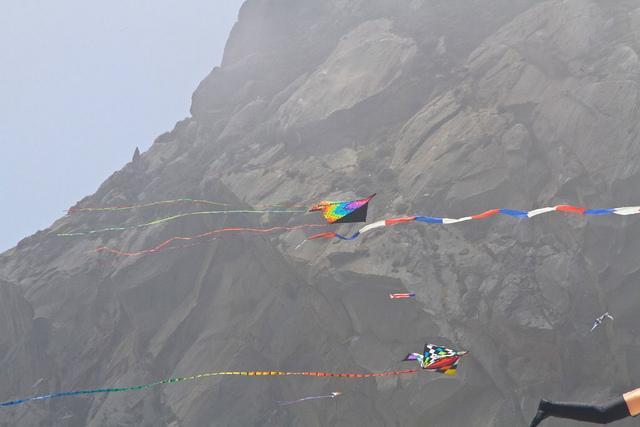How many kites are in the picture?
Give a very brief answer. 2. How many horses are in the photo?
Give a very brief answer. 0. 